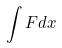Convert formula to latex. <formula><loc_0><loc_0><loc_500><loc_500>\int F d x</formula> 